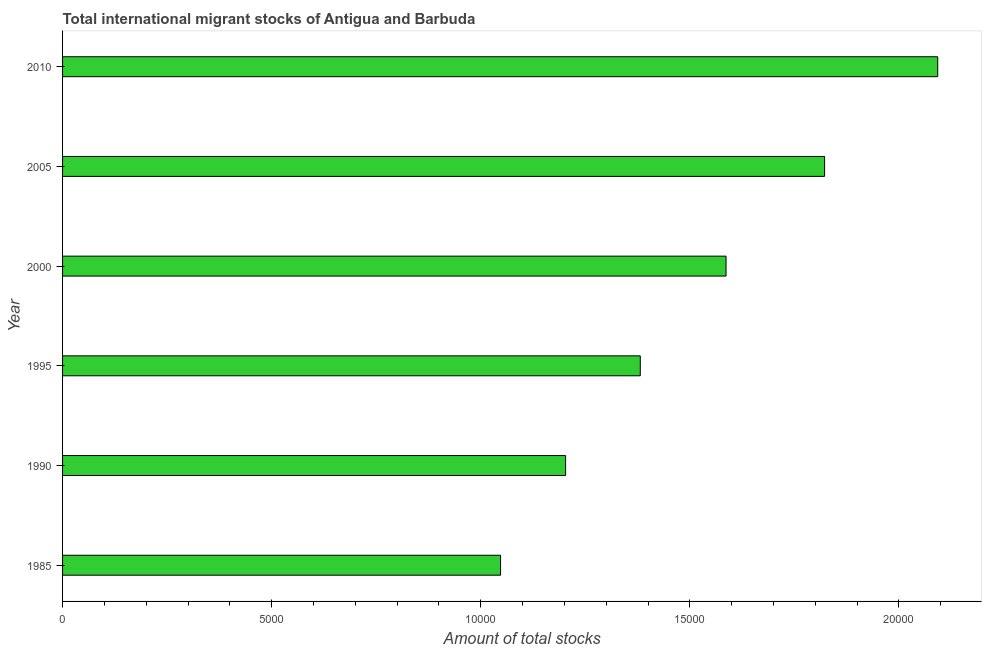Does the graph contain any zero values?
Ensure brevity in your answer.  No. Does the graph contain grids?
Your answer should be very brief. No. What is the title of the graph?
Provide a succinct answer. Total international migrant stocks of Antigua and Barbuda. What is the label or title of the X-axis?
Your response must be concise. Amount of total stocks. What is the total number of international migrant stock in 2000?
Provide a short and direct response. 1.59e+04. Across all years, what is the maximum total number of international migrant stock?
Make the answer very short. 2.09e+04. Across all years, what is the minimum total number of international migrant stock?
Ensure brevity in your answer.  1.05e+04. What is the sum of the total number of international migrant stock?
Provide a short and direct response. 9.13e+04. What is the difference between the total number of international migrant stock in 1995 and 2000?
Offer a very short reply. -2051. What is the average total number of international migrant stock per year?
Keep it short and to the point. 1.52e+04. What is the median total number of international migrant stock?
Provide a succinct answer. 1.48e+04. Do a majority of the years between 1990 and 2005 (inclusive) have total number of international migrant stock greater than 15000 ?
Offer a terse response. No. What is the ratio of the total number of international migrant stock in 2000 to that in 2005?
Offer a terse response. 0.87. What is the difference between the highest and the second highest total number of international migrant stock?
Your answer should be compact. 2706. Is the sum of the total number of international migrant stock in 2000 and 2005 greater than the maximum total number of international migrant stock across all years?
Make the answer very short. Yes. What is the difference between the highest and the lowest total number of international migrant stock?
Keep it short and to the point. 1.05e+04. How many bars are there?
Make the answer very short. 6. What is the Amount of total stocks in 1985?
Give a very brief answer. 1.05e+04. What is the Amount of total stocks of 1990?
Offer a very short reply. 1.20e+04. What is the Amount of total stocks of 1995?
Provide a succinct answer. 1.38e+04. What is the Amount of total stocks in 2000?
Your answer should be very brief. 1.59e+04. What is the Amount of total stocks of 2005?
Your response must be concise. 1.82e+04. What is the Amount of total stocks of 2010?
Provide a short and direct response. 2.09e+04. What is the difference between the Amount of total stocks in 1985 and 1990?
Your answer should be very brief. -1555. What is the difference between the Amount of total stocks in 1985 and 1995?
Offer a terse response. -3341. What is the difference between the Amount of total stocks in 1985 and 2000?
Provide a short and direct response. -5392. What is the difference between the Amount of total stocks in 1985 and 2005?
Offer a terse response. -7748. What is the difference between the Amount of total stocks in 1985 and 2010?
Offer a terse response. -1.05e+04. What is the difference between the Amount of total stocks in 1990 and 1995?
Give a very brief answer. -1786. What is the difference between the Amount of total stocks in 1990 and 2000?
Your answer should be very brief. -3837. What is the difference between the Amount of total stocks in 1990 and 2005?
Ensure brevity in your answer.  -6193. What is the difference between the Amount of total stocks in 1990 and 2010?
Make the answer very short. -8899. What is the difference between the Amount of total stocks in 1995 and 2000?
Provide a short and direct response. -2051. What is the difference between the Amount of total stocks in 1995 and 2005?
Your response must be concise. -4407. What is the difference between the Amount of total stocks in 1995 and 2010?
Keep it short and to the point. -7113. What is the difference between the Amount of total stocks in 2000 and 2005?
Make the answer very short. -2356. What is the difference between the Amount of total stocks in 2000 and 2010?
Provide a succinct answer. -5062. What is the difference between the Amount of total stocks in 2005 and 2010?
Offer a very short reply. -2706. What is the ratio of the Amount of total stocks in 1985 to that in 1990?
Provide a short and direct response. 0.87. What is the ratio of the Amount of total stocks in 1985 to that in 1995?
Make the answer very short. 0.76. What is the ratio of the Amount of total stocks in 1985 to that in 2000?
Your answer should be very brief. 0.66. What is the ratio of the Amount of total stocks in 1985 to that in 2005?
Offer a very short reply. 0.57. What is the ratio of the Amount of total stocks in 1990 to that in 1995?
Provide a succinct answer. 0.87. What is the ratio of the Amount of total stocks in 1990 to that in 2000?
Your response must be concise. 0.76. What is the ratio of the Amount of total stocks in 1990 to that in 2005?
Your answer should be very brief. 0.66. What is the ratio of the Amount of total stocks in 1990 to that in 2010?
Your response must be concise. 0.57. What is the ratio of the Amount of total stocks in 1995 to that in 2000?
Keep it short and to the point. 0.87. What is the ratio of the Amount of total stocks in 1995 to that in 2005?
Give a very brief answer. 0.76. What is the ratio of the Amount of total stocks in 1995 to that in 2010?
Offer a very short reply. 0.66. What is the ratio of the Amount of total stocks in 2000 to that in 2005?
Ensure brevity in your answer.  0.87. What is the ratio of the Amount of total stocks in 2000 to that in 2010?
Offer a terse response. 0.76. What is the ratio of the Amount of total stocks in 2005 to that in 2010?
Offer a very short reply. 0.87. 